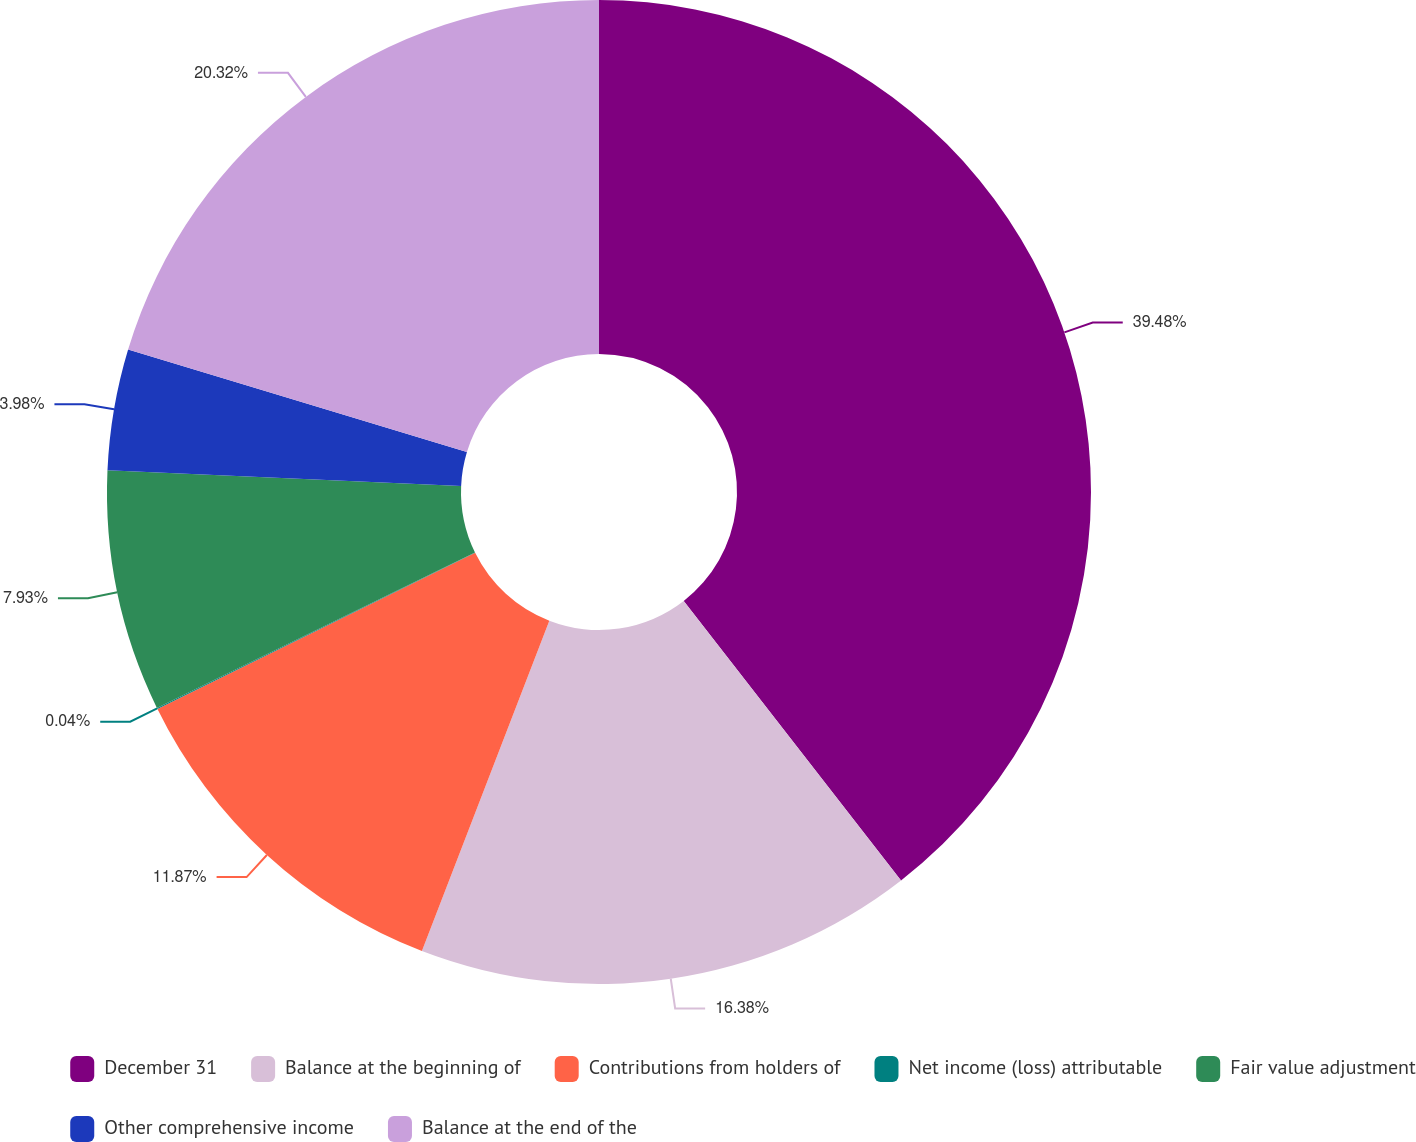Convert chart. <chart><loc_0><loc_0><loc_500><loc_500><pie_chart><fcel>December 31<fcel>Balance at the beginning of<fcel>Contributions from holders of<fcel>Net income (loss) attributable<fcel>Fair value adjustment<fcel>Other comprehensive income<fcel>Balance at the end of the<nl><fcel>39.48%<fcel>16.38%<fcel>11.87%<fcel>0.04%<fcel>7.93%<fcel>3.98%<fcel>20.32%<nl></chart> 